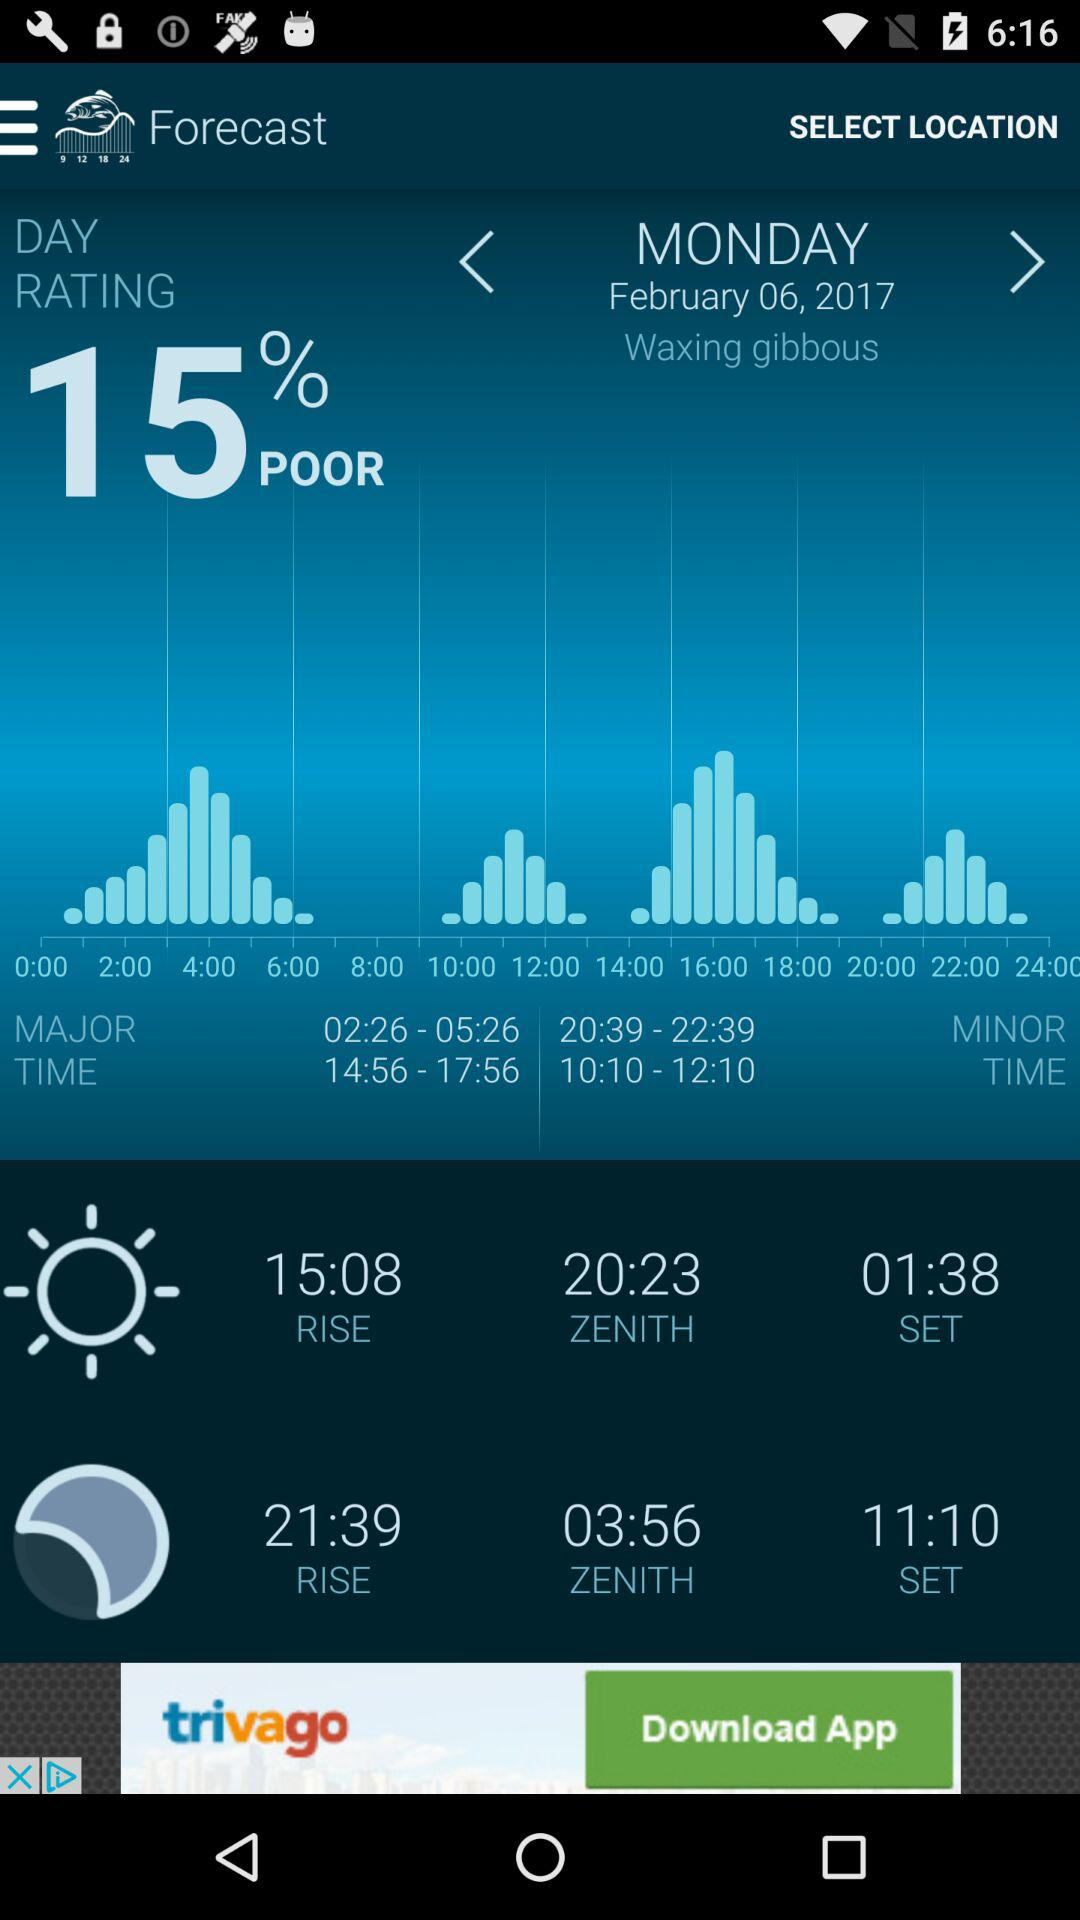What is the day rating? The rating of the day is 15 % poor. 